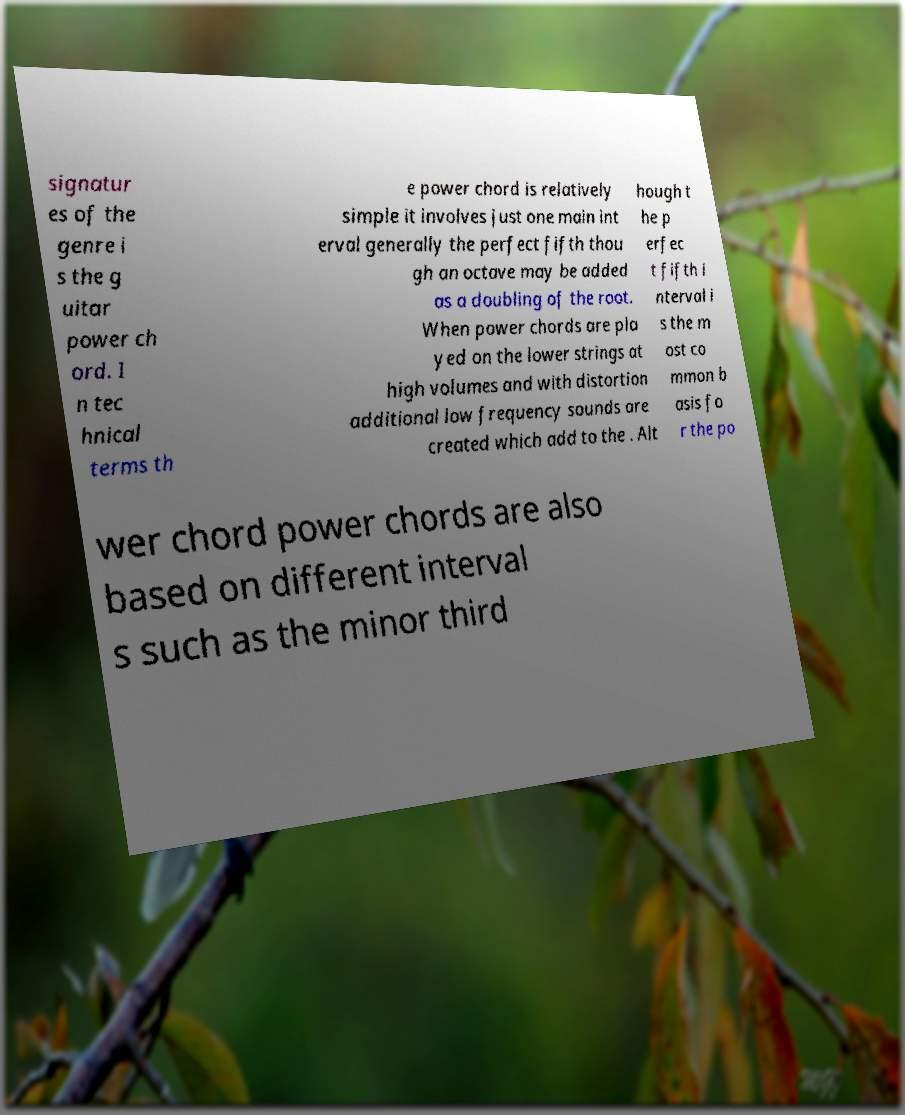Could you assist in decoding the text presented in this image and type it out clearly? signatur es of the genre i s the g uitar power ch ord. I n tec hnical terms th e power chord is relatively simple it involves just one main int erval generally the perfect fifth thou gh an octave may be added as a doubling of the root. When power chords are pla yed on the lower strings at high volumes and with distortion additional low frequency sounds are created which add to the . Alt hough t he p erfec t fifth i nterval i s the m ost co mmon b asis fo r the po wer chord power chords are also based on different interval s such as the minor third 